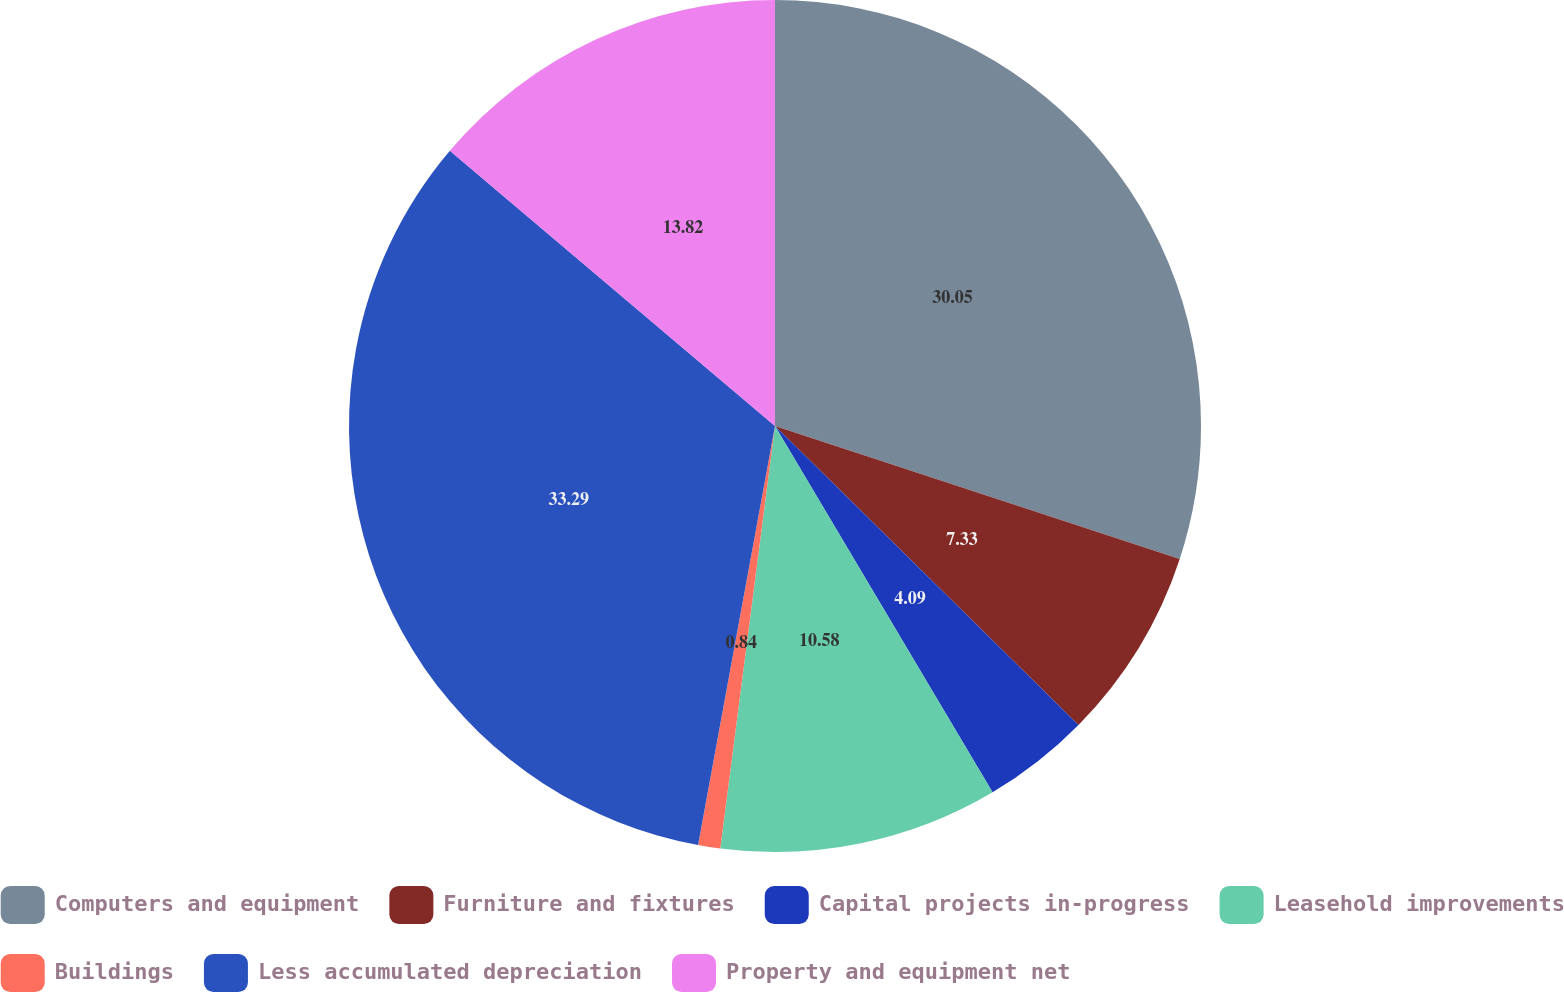<chart> <loc_0><loc_0><loc_500><loc_500><pie_chart><fcel>Computers and equipment<fcel>Furniture and fixtures<fcel>Capital projects in-progress<fcel>Leasehold improvements<fcel>Buildings<fcel>Less accumulated depreciation<fcel>Property and equipment net<nl><fcel>30.05%<fcel>7.33%<fcel>4.09%<fcel>10.58%<fcel>0.84%<fcel>33.29%<fcel>13.82%<nl></chart> 